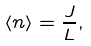Convert formula to latex. <formula><loc_0><loc_0><loc_500><loc_500>\left \langle n \right \rangle = \frac { J } { L } , \,</formula> 